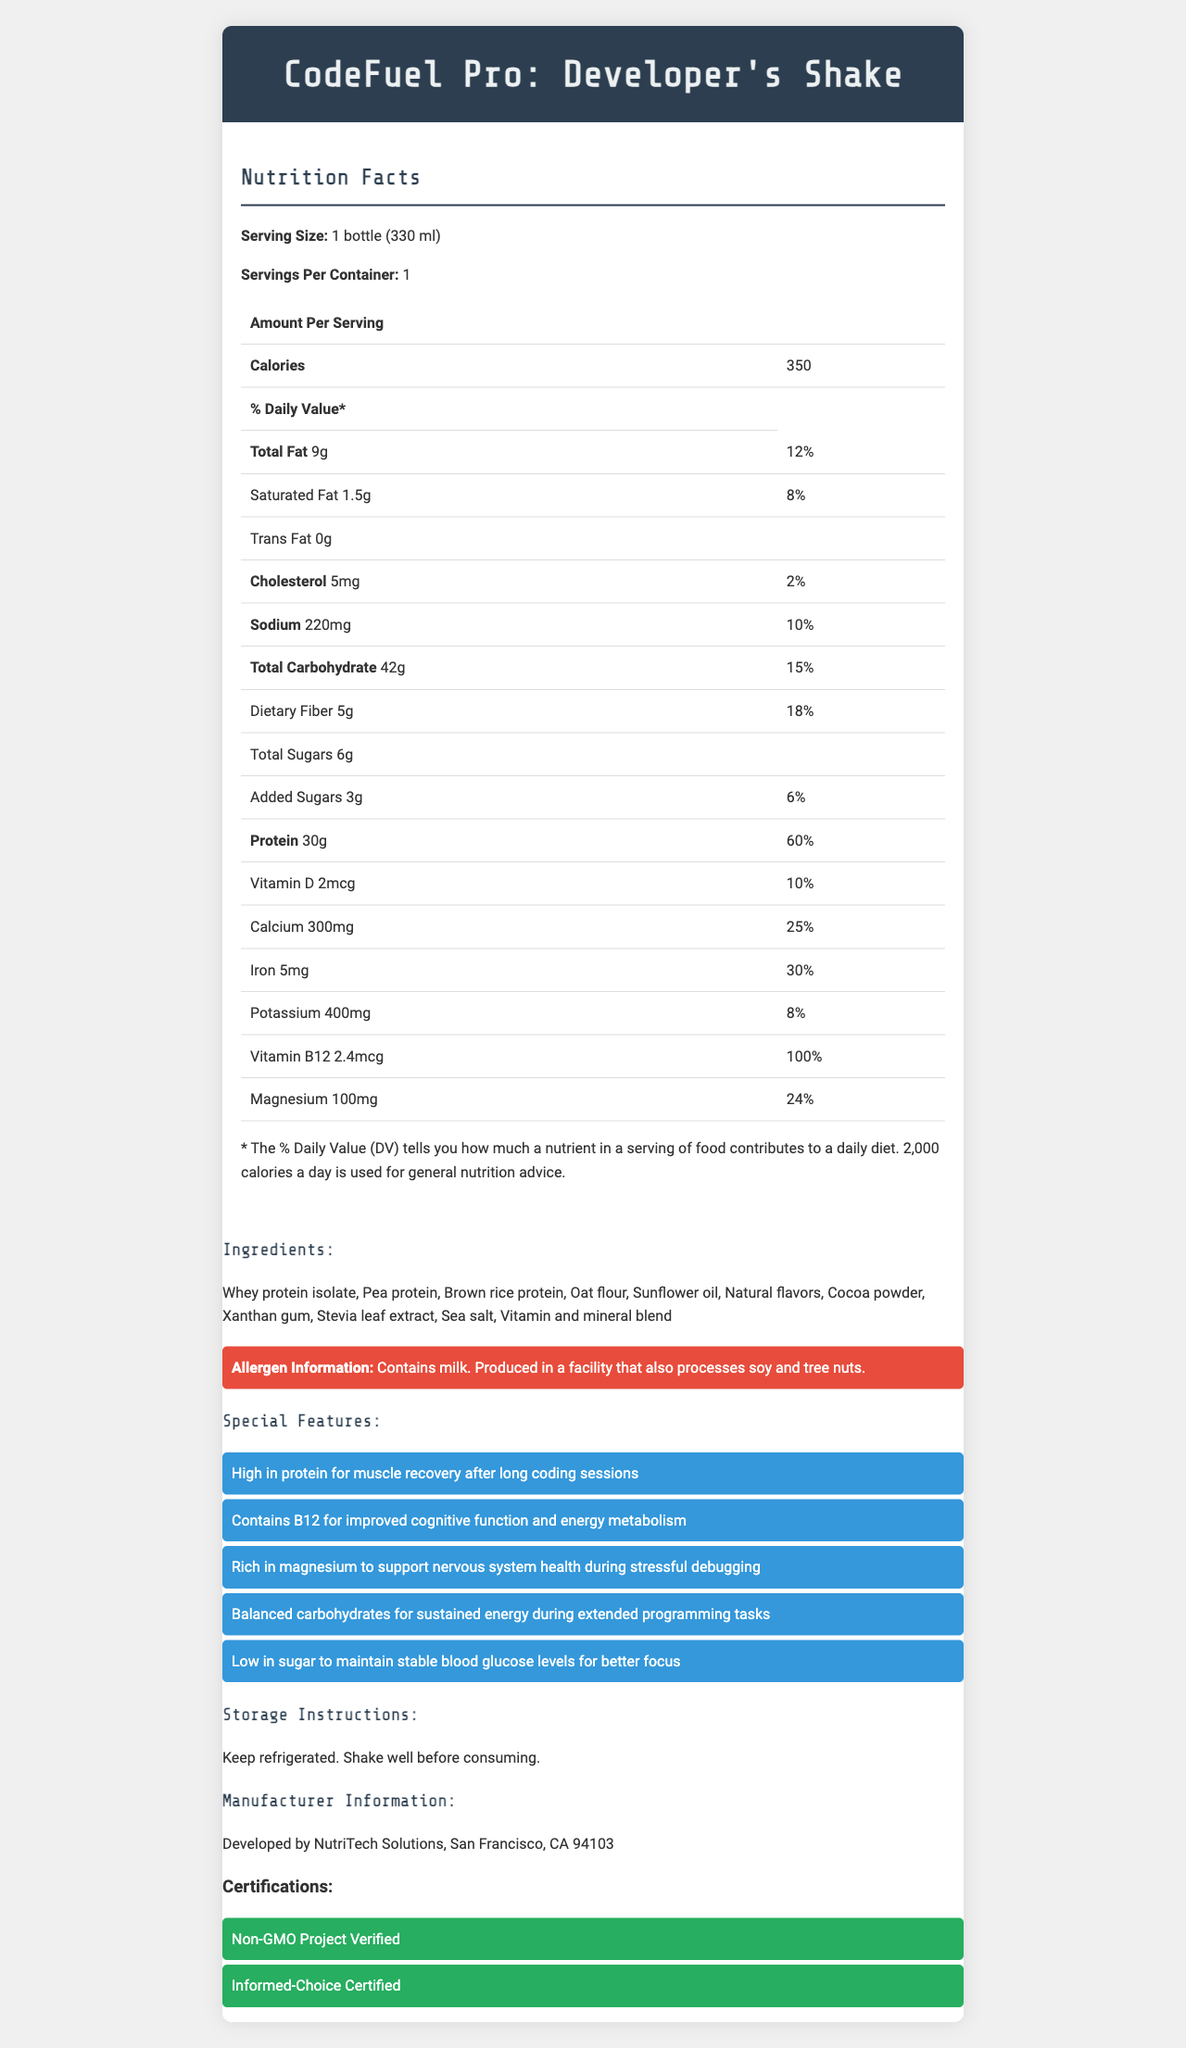what is the serving size of CodeFuel Pro? The serving size is clearly labeled as "1 bottle (330 ml)" in the document.
Answer: 1 bottle (330 ml) how many calories are there per serving? The document lists 350 calories per serving under the nutrition facts.
Answer: 350 calories what is the amount of total fat per serving? The document states that each serving contains 9 grams of total fat.
Answer: 9g how much protein does one serving of the shake provide? According to the nutrition facts, each serving contains 30 grams of protein.
Answer: 30g what is the percentage of daily value for calcium in one serving? The daily value of calcium per serving is listed as 25%.
Answer: 25% which company manufactures CodeFuel Pro: Developer's Shake? The manufacturer information section states that the product is developed by NutriTech Solutions.
Answer: NutriTech Solutions does the shake contain any allergenic ingredients? The allergen information mentions that the shake contains milk and may be processed in a facility that also handles soy and tree nuts.
Answer: Yes what is the benefit of vitamin B12 in the shake? The special features list includes vitamin B12 for improved cognitive function and energy metabolism.
Answer: Improved cognitive function and energy metabolism which of the following is a special feature of CodeFuel Pro? A. Low in protein B. High in sugar C. High in protein D. Low in fiber The document states that one of the special features is that the shake is high in protein for muscle recovery after long coding sessions.
Answer: C. High in protein which certification signifies that the product is not genetically modified? A. Informed-Choice Certified B. Non-GMO Project Verified C. Gluten-Free Certified D. USDA Organic The certifications section includes "Non-GMO Project Verified," indicating that the product is not genetically modified.
Answer: B. Non-GMO Project Verified is the shake suitable for those trying to limit their sugar intake? The shake is low in sugar, with only 6 grams of total sugars and 3 grams of added sugars per serving, which helps maintain stable blood glucose levels for better focus.
Answer: Yes does the document state how many servings are in one container? The document states that there is 1 serving per container.
Answer: Yes summarize the nutrition benefits of CodeFuel Pro: Developer's Shake for busy software developers. The shake offers high protein to support muscle recovery, vitamin B12 for cognitive function and energy metabolism, balanced carbohydrates for sustained energy, and low sugar content to maintain stable blood glucose levels. It is also rich in magnesium, supporting nervous system health during stressful debugging sessions.
Answer: The CodeFuel Pro: Developer's Shake is designed to provide high protein, low sugar, and essential vitamins and minerals. It supports muscle recovery with 30 grams of protein per serving, enhances cognitive function with vitamin B12, and helps with energy metabolism and nervous system health during stressful tasks, making it ideal for busy software developers. where is NutriTech Solutions, the manufacturer, located? The manufacturer information section states that NutriTech Solutions is located in San Francisco, CA 94103.
Answer: San Francisco, CA 94103 how many grams of dietary fiber does each serving contain? The document lists 5 grams of dietary fiber per serving under the nutrition facts.
Answer: 5g what is the total amount of fat in the entire bottle if I drink it all? Since there is 1 serving per container and each serving contains 9 grams of total fat, the entire bottle has 9 grams of total fat.
Answer: 9g what is the recommended storage condition for the shake? The storage instructions state that the shake should be kept refrigerated.
Answer: Keep refrigerated why is there an asterisk (*) next to the % Daily Value section in the nutrition facts? The document includes a note explaining that the % Daily Value indicates the contribution of a nutrient in a serving of food to a daily diet, based on a 2,000 calorie daily intake.
Answer: The % Daily Value tells you how much a nutrient in a serving of food contributes to a daily diet based on a 2,000 calorie diet. what is the total amount of cholesterol in the entire bottle if I drink it all? Since there is 1 serving per container and each serving contains 5 milligrams of cholesterol, the entire bottle has 5 milligrams of cholesterol.
Answer: 5mg can I find out the price of CodeFuel Pro: Developer's Shake from this document? The document does not provide any information regarding the price of the shake.
Answer: Cannot be determined 